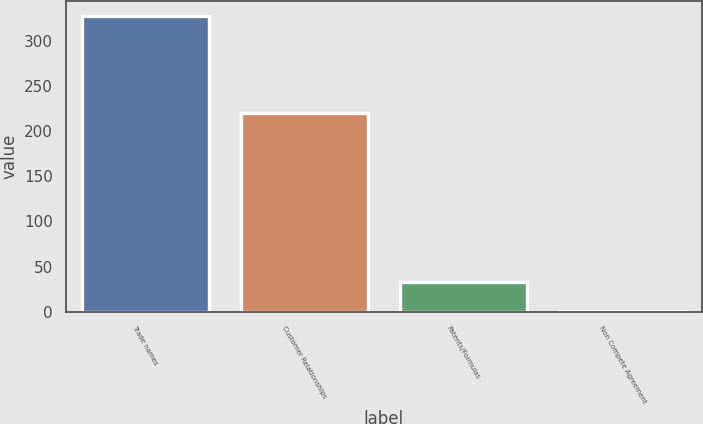Convert chart to OTSL. <chart><loc_0><loc_0><loc_500><loc_500><bar_chart><fcel>Trade names<fcel>Customer Relationships<fcel>Patents/Formulas<fcel>Non Compete Agreement<nl><fcel>327.6<fcel>220.2<fcel>32.94<fcel>0.2<nl></chart> 